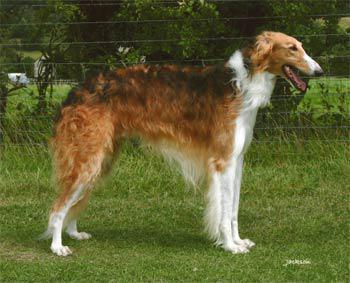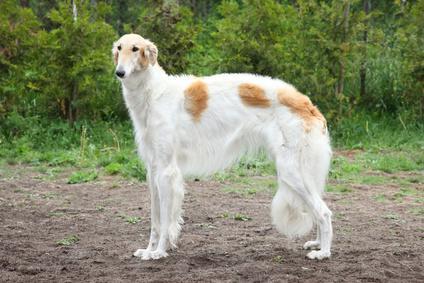The first image is the image on the left, the second image is the image on the right. Analyze the images presented: Is the assertion "The dogs in the image on the left are facing right." valid? Answer yes or no. Yes. 